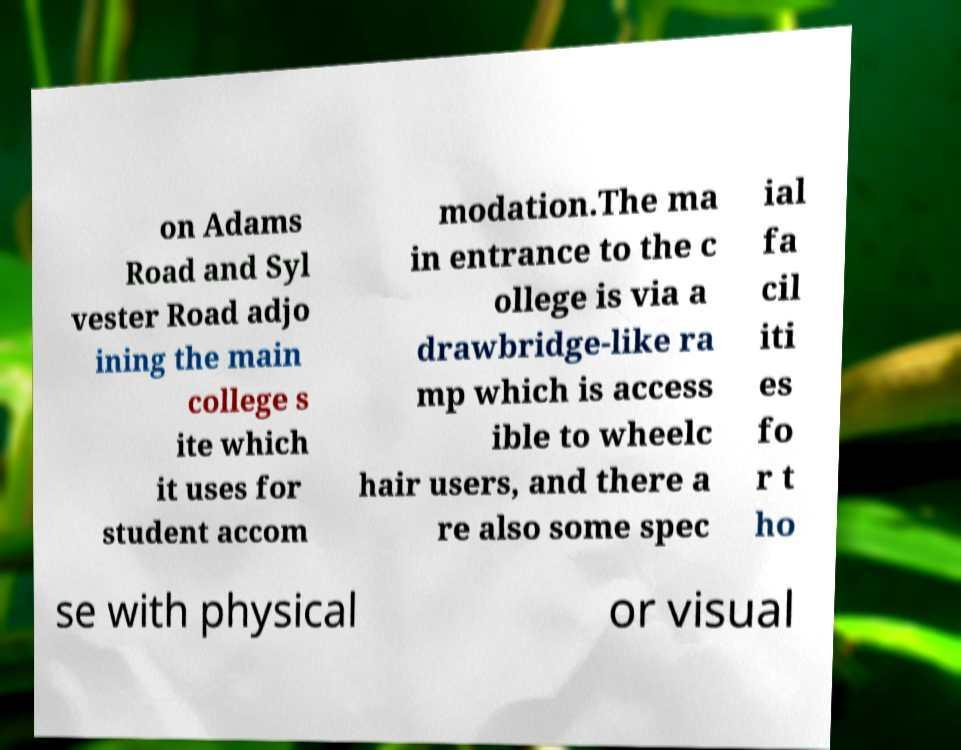I need the written content from this picture converted into text. Can you do that? on Adams Road and Syl vester Road adjo ining the main college s ite which it uses for student accom modation.The ma in entrance to the c ollege is via a drawbridge-like ra mp which is access ible to wheelc hair users, and there a re also some spec ial fa cil iti es fo r t ho se with physical or visual 